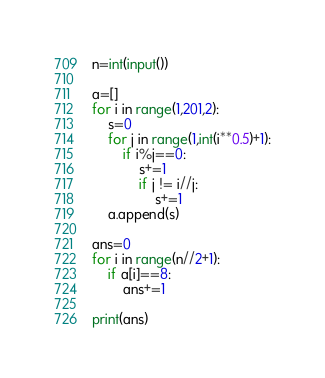<code> <loc_0><loc_0><loc_500><loc_500><_Python_>n=int(input())

a=[]
for i in range(1,201,2):
    s=0
    for j in range(1,int(i**0.5)+1):
        if i%j==0:
            s+=1
            if j != i//j:
                s+=1
    a.append(s)

ans=0
for i in range(n//2+1):
    if a[i]==8:
        ans+=1

print(ans)</code> 